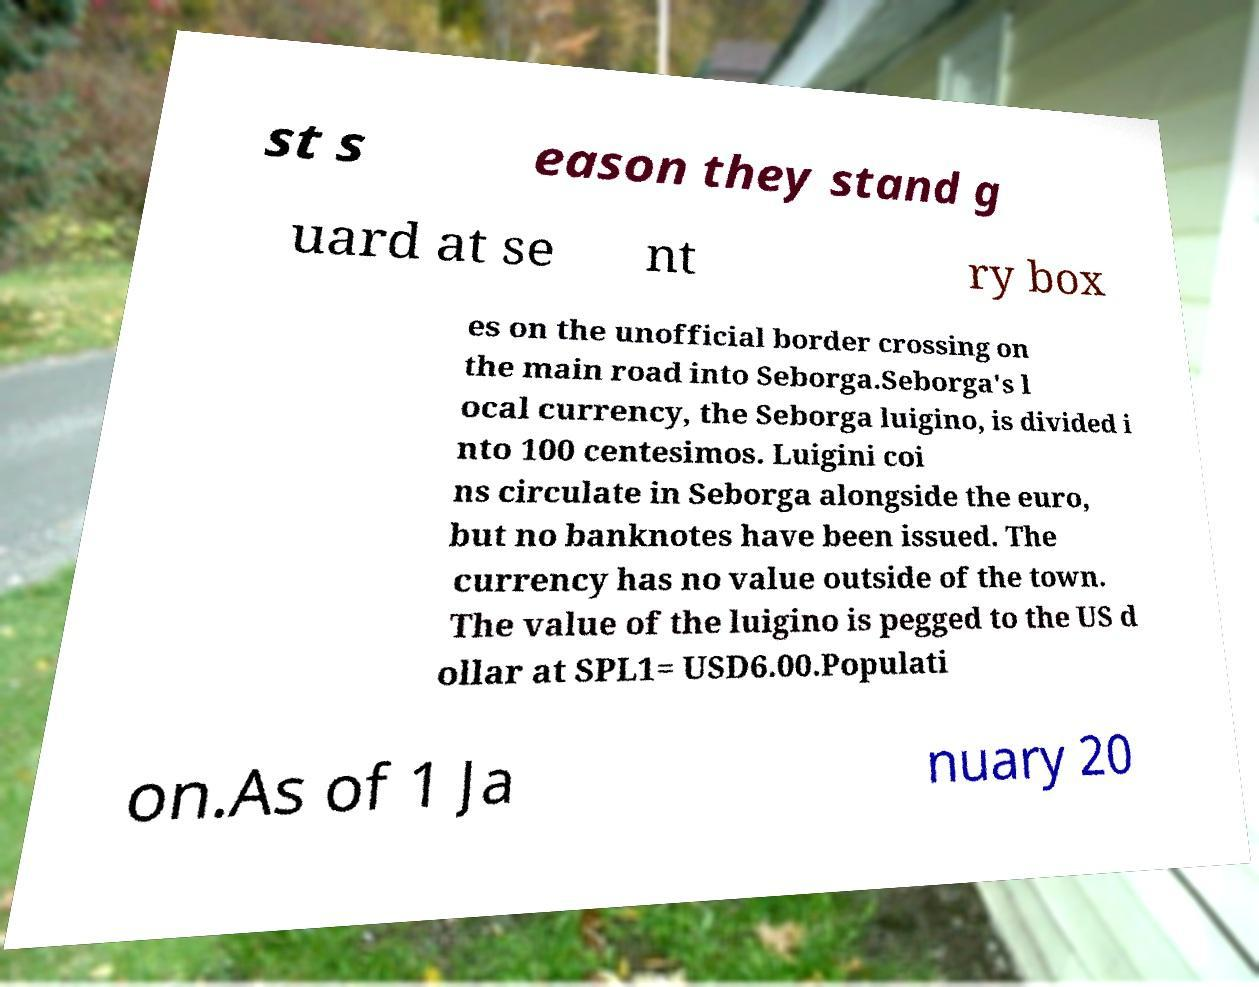Could you assist in decoding the text presented in this image and type it out clearly? st s eason they stand g uard at se nt ry box es on the unofficial border crossing on the main road into Seborga.Seborga's l ocal currency, the Seborga luigino, is divided i nto 100 centesimos. Luigini coi ns circulate in Seborga alongside the euro, but no banknotes have been issued. The currency has no value outside of the town. The value of the luigino is pegged to the US d ollar at SPL1= USD6.00.Populati on.As of 1 Ja nuary 20 